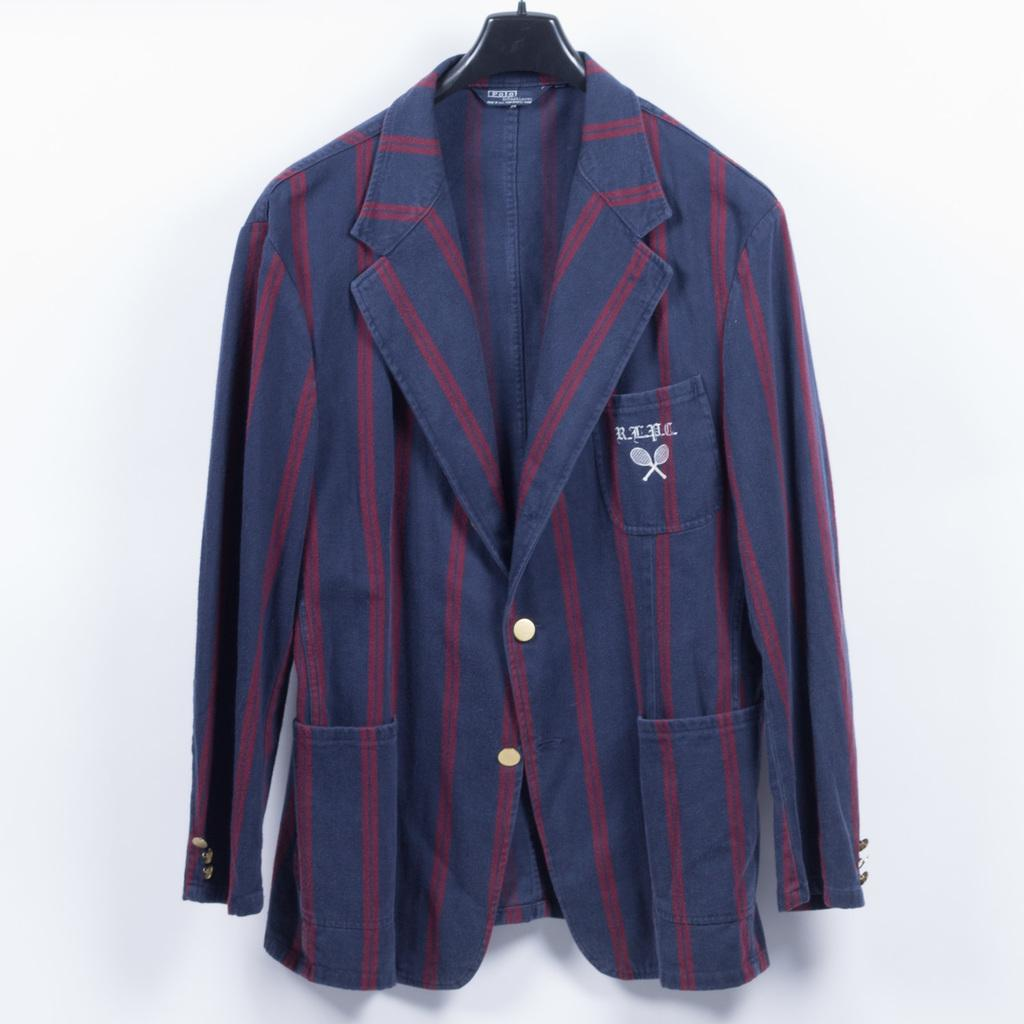What type of clothing item is in the image? There is a suit jacket in the image. How is the suit jacket positioned in the image? The suit jacket is on a hanger. What color is the background of the image? The background of the image is white. What type of thing is the turkey holding in the image? There is no turkey present in the image, so it is not possible to answer that question. 